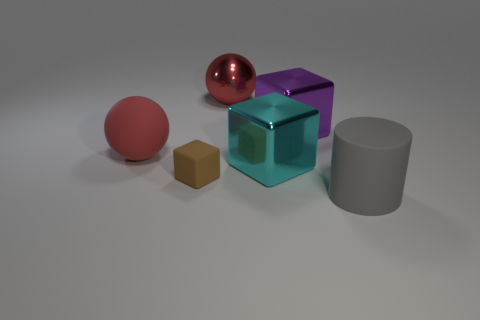What number of cubes are to the right of the large red shiny sphere and to the left of the big purple cube?
Provide a succinct answer. 1. What is the color of the large metallic object that is in front of the big matte thing on the left side of the matte thing right of the tiny matte cube?
Your answer should be very brief. Cyan. How many small brown cubes are right of the red thing to the right of the brown matte object?
Offer a terse response. 0. How many other objects are there of the same shape as the brown thing?
Your answer should be compact. 2. How many things are either big brown matte spheres or big shiny things that are on the left side of the purple block?
Ensure brevity in your answer.  2. Is the number of big red spheres left of the red metal ball greater than the number of large purple metallic cubes left of the large matte cylinder?
Offer a very short reply. No. What shape is the big metallic thing that is in front of the cube that is behind the big rubber thing on the left side of the cylinder?
Your answer should be very brief. Cube. There is a red thing behind the large ball that is in front of the large purple metal block; what is its shape?
Provide a succinct answer. Sphere. Are there any big purple blocks made of the same material as the large cylinder?
Offer a very short reply. No. There is a rubber sphere that is the same color as the metal ball; what size is it?
Keep it short and to the point. Large. 